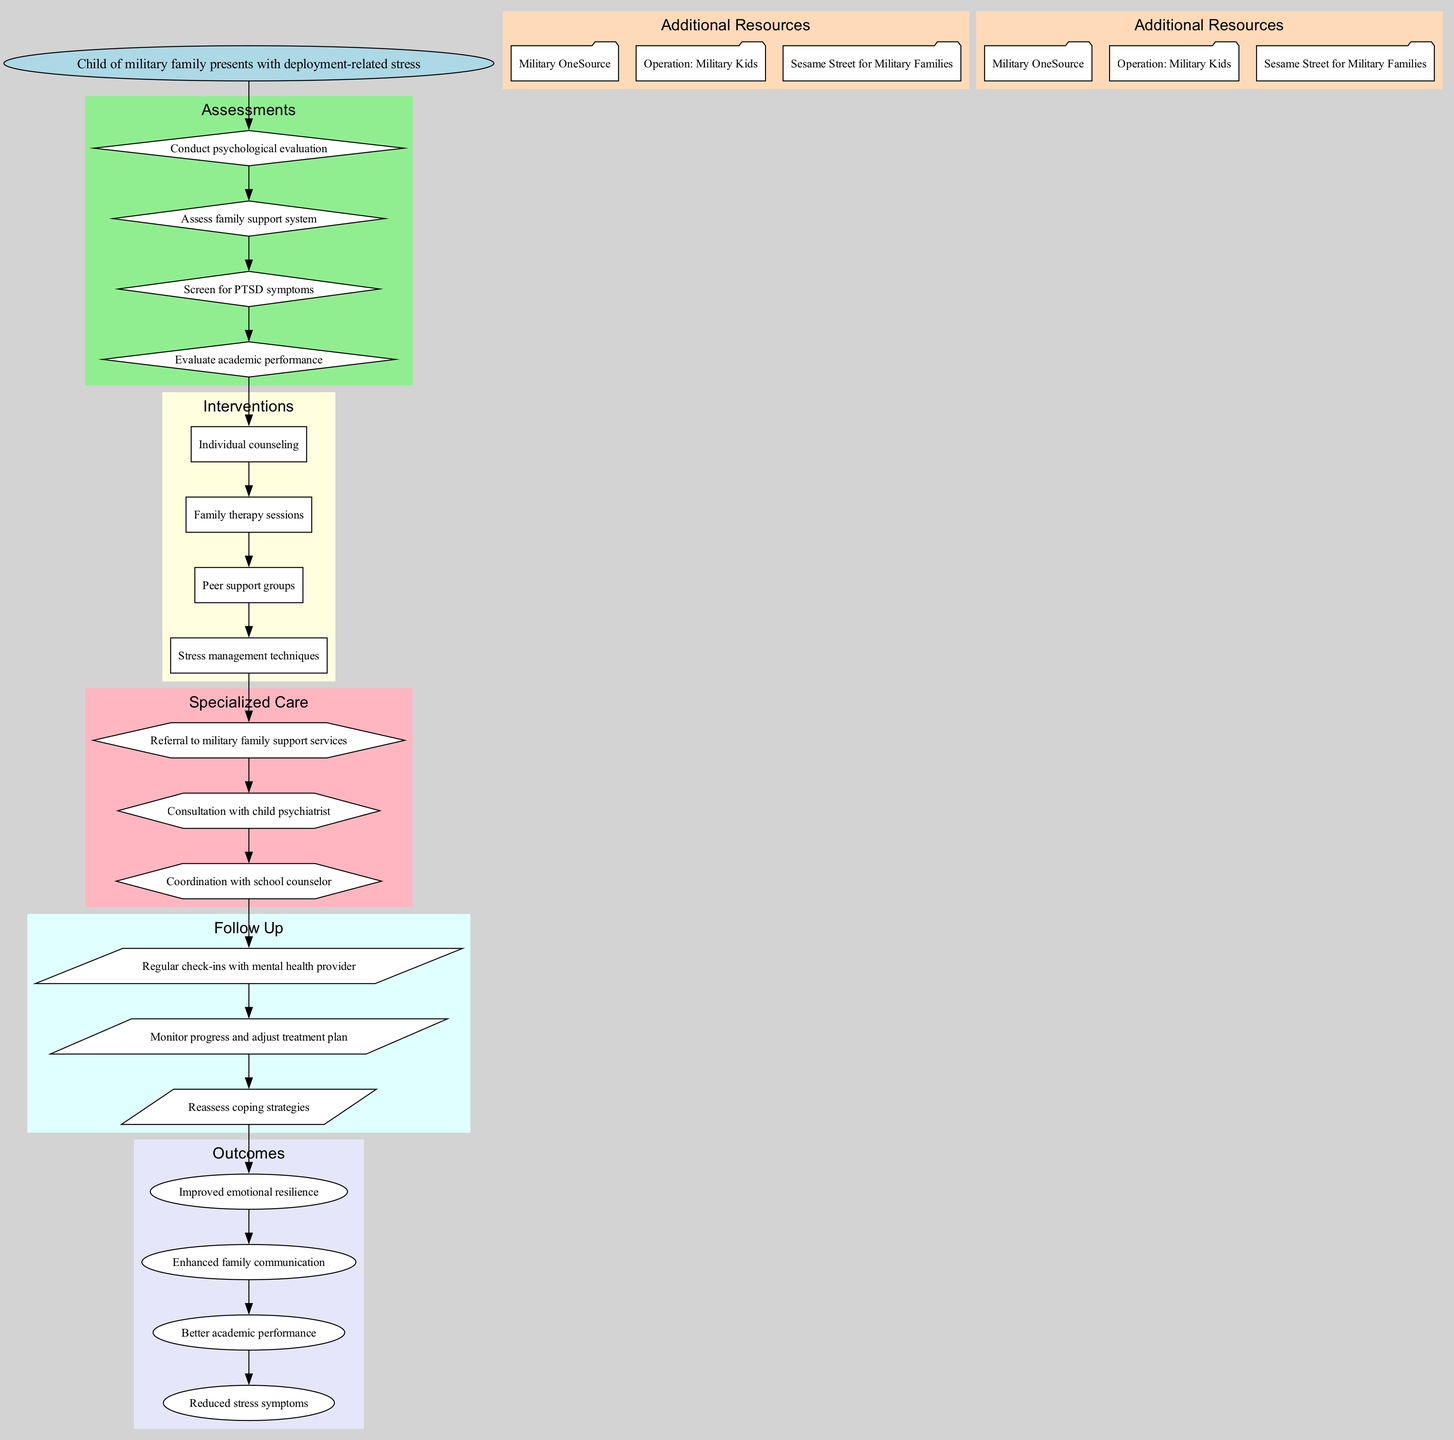What is the starting point of the clinical pathway? The diagram begins with the node labeled "Child of military family presents with deployment-related stress," indicating the initial state or situation that triggers the clinical pathway.
Answer: Child of military family presents with deployment-related stress How many assessments are listed in the diagram? By counting the nodes in the "assessments" section, we determine that there are four different types of assessments mentioned in the pathway.
Answer: 4 What is the last step before follow-up in the clinical pathway? The last intervention step before moving to follow-up is indicated as "Consultation with child psychiatrist," which leads into the follow-up section.
Answer: Consultation with child psychiatrist Which specialized care option follows interventions? The first specialized care option listed after the interventions is "Referral to military family support services," showing the transition from intervention to specialized care.
Answer: Referral to military family support services What is one outcome expected from the clinical pathway? According to the pathway, one of the expected outcomes is "Improved emotional resilience," which indicates the goal of the entire treatment process.
Answer: Improved emotional resilience What type of resource can be found in the additional resources section? The diagram includes multiple entries in the additional resources section, and one of those is "Military OneSource," providing support for military families.
Answer: Military OneSource What follows after monitoring progress in the follow-up phase? In the follow-up phase, after "Monitor progress and adjust treatment plan," the next step is "Reassess coping strategies," which continues the process of evaluation and adjustment.
Answer: Reassess coping strategies What connects the assessments to the interventions? The last assessment, represented as "Evaluate academic performance," directly connects through an edge leading to the first intervention, indicating the flow of the pathway.
Answer: Evaluate academic performance Which type of node represents the interventions in the diagram? The interventions are represented in the diagram by nodes shaped like boxes, distinguishing them from other types of nodes in the clinical pathway structure.
Answer: Box 